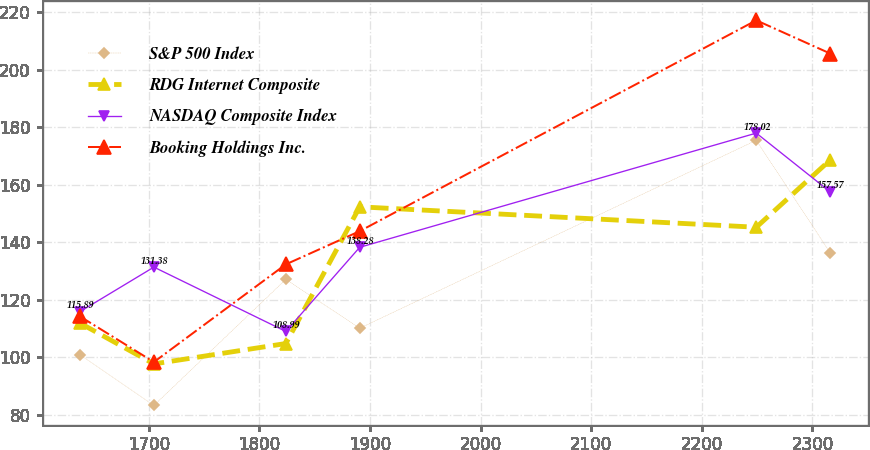Convert chart to OTSL. <chart><loc_0><loc_0><loc_500><loc_500><line_chart><ecel><fcel>S&P 500 Index<fcel>RDG Internet Composite<fcel>NASDAQ Composite Index<fcel>Booking Holdings Inc.<nl><fcel>1637.82<fcel>100.89<fcel>111.89<fcel>115.89<fcel>114.21<nl><fcel>1704.61<fcel>83.23<fcel>97.69<fcel>131.38<fcel>98.34<nl><fcel>1823.91<fcel>127.13<fcel>104.79<fcel>108.99<fcel>132.34<nl><fcel>1890.7<fcel>110.12<fcel>152.36<fcel>138.28<fcel>143.89<nl><fcel>2249.25<fcel>175.52<fcel>145.26<fcel>178.02<fcel>217.27<nl><fcel>2316.04<fcel>136.36<fcel>168.65<fcel>157.57<fcel>205.72<nl></chart> 